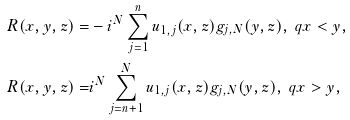<formula> <loc_0><loc_0><loc_500><loc_500>R ( x , y , z ) = & - i ^ { N } \sum _ { j = 1 } ^ { n } u _ { 1 , j } ( x , z ) g _ { j , N } ( y , z ) , \ q x < y , \\ R ( x , y , z ) = & i ^ { N } \sum _ { j = n + 1 } ^ { N } u _ { 1 , j } ( x , z ) g _ { j , N } ( y , z ) , \ q x > y ,</formula> 